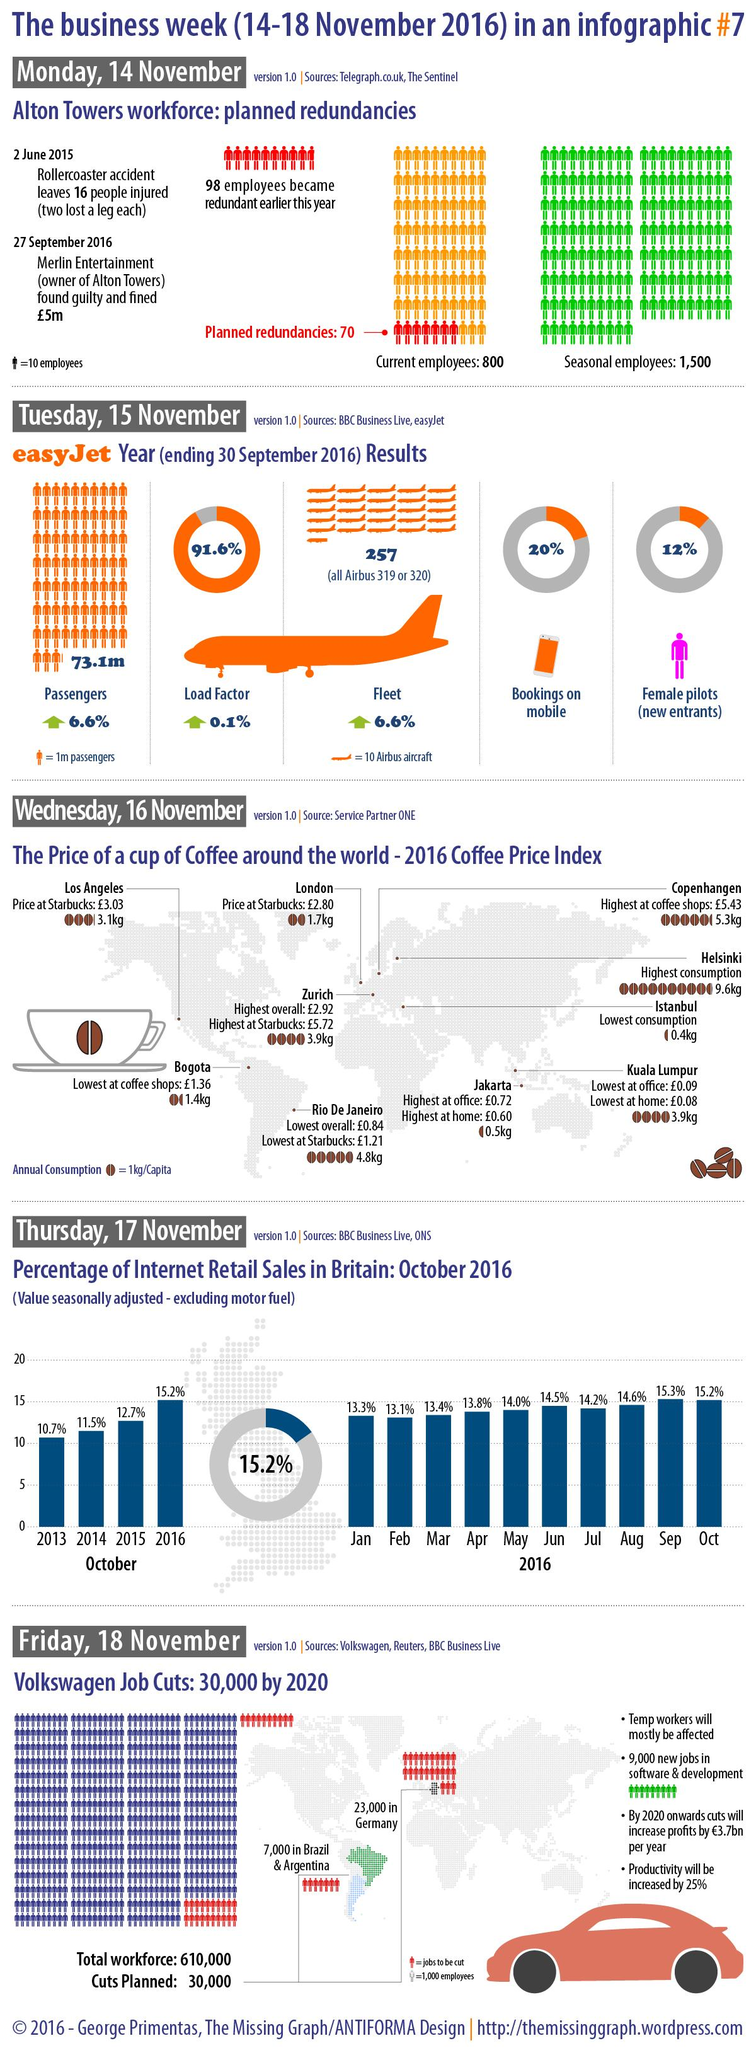List a handful of essential elements in this visual. According to the given data, the total internet retail sales in September and October combined was 30.5%. Eighty percent of bookings are not made through mobile devices. According to a recent survey, 88% of pilots are not female. The highest sales for internet retail occur in the month of September. In 2014 and 2015, the combined percentage of internet retail sales was 24.2%. 